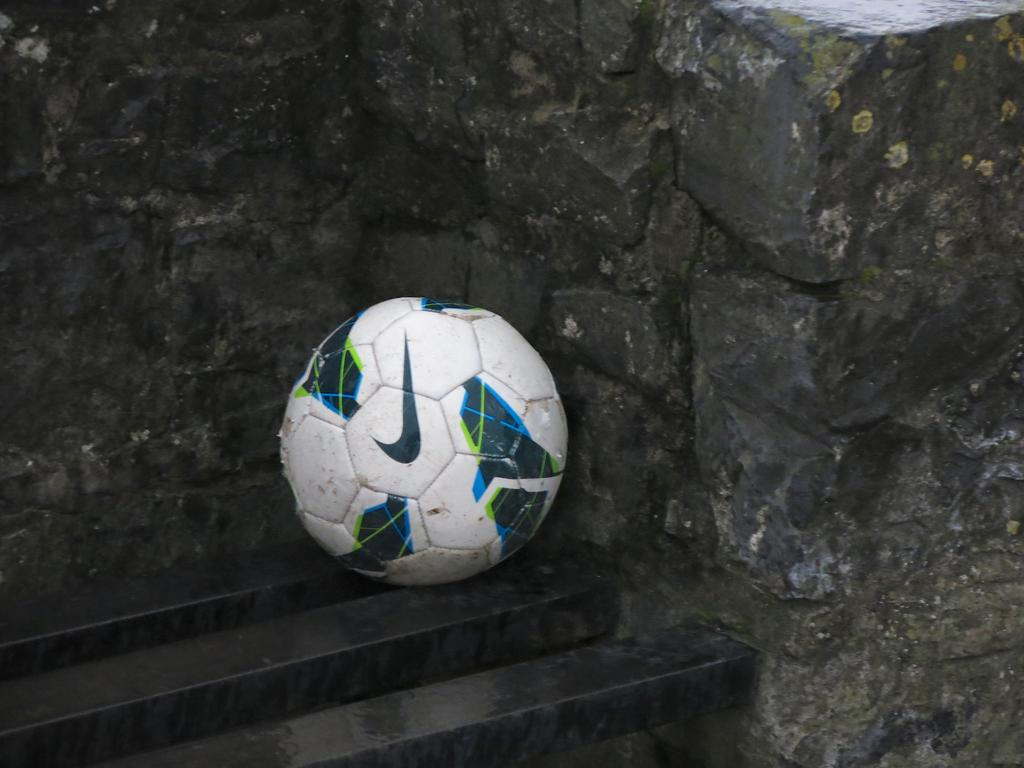What is the main object in the center of the image? There is a ball in the center of the image. Where is the ball located? The ball is on the stairs. What can be seen behind the ball? There are rocks behind the ball. What type of sugar is being used to sweeten the car in the image? There is no car or sugar present in the image; it features a ball on the stairs with rocks behind it. 